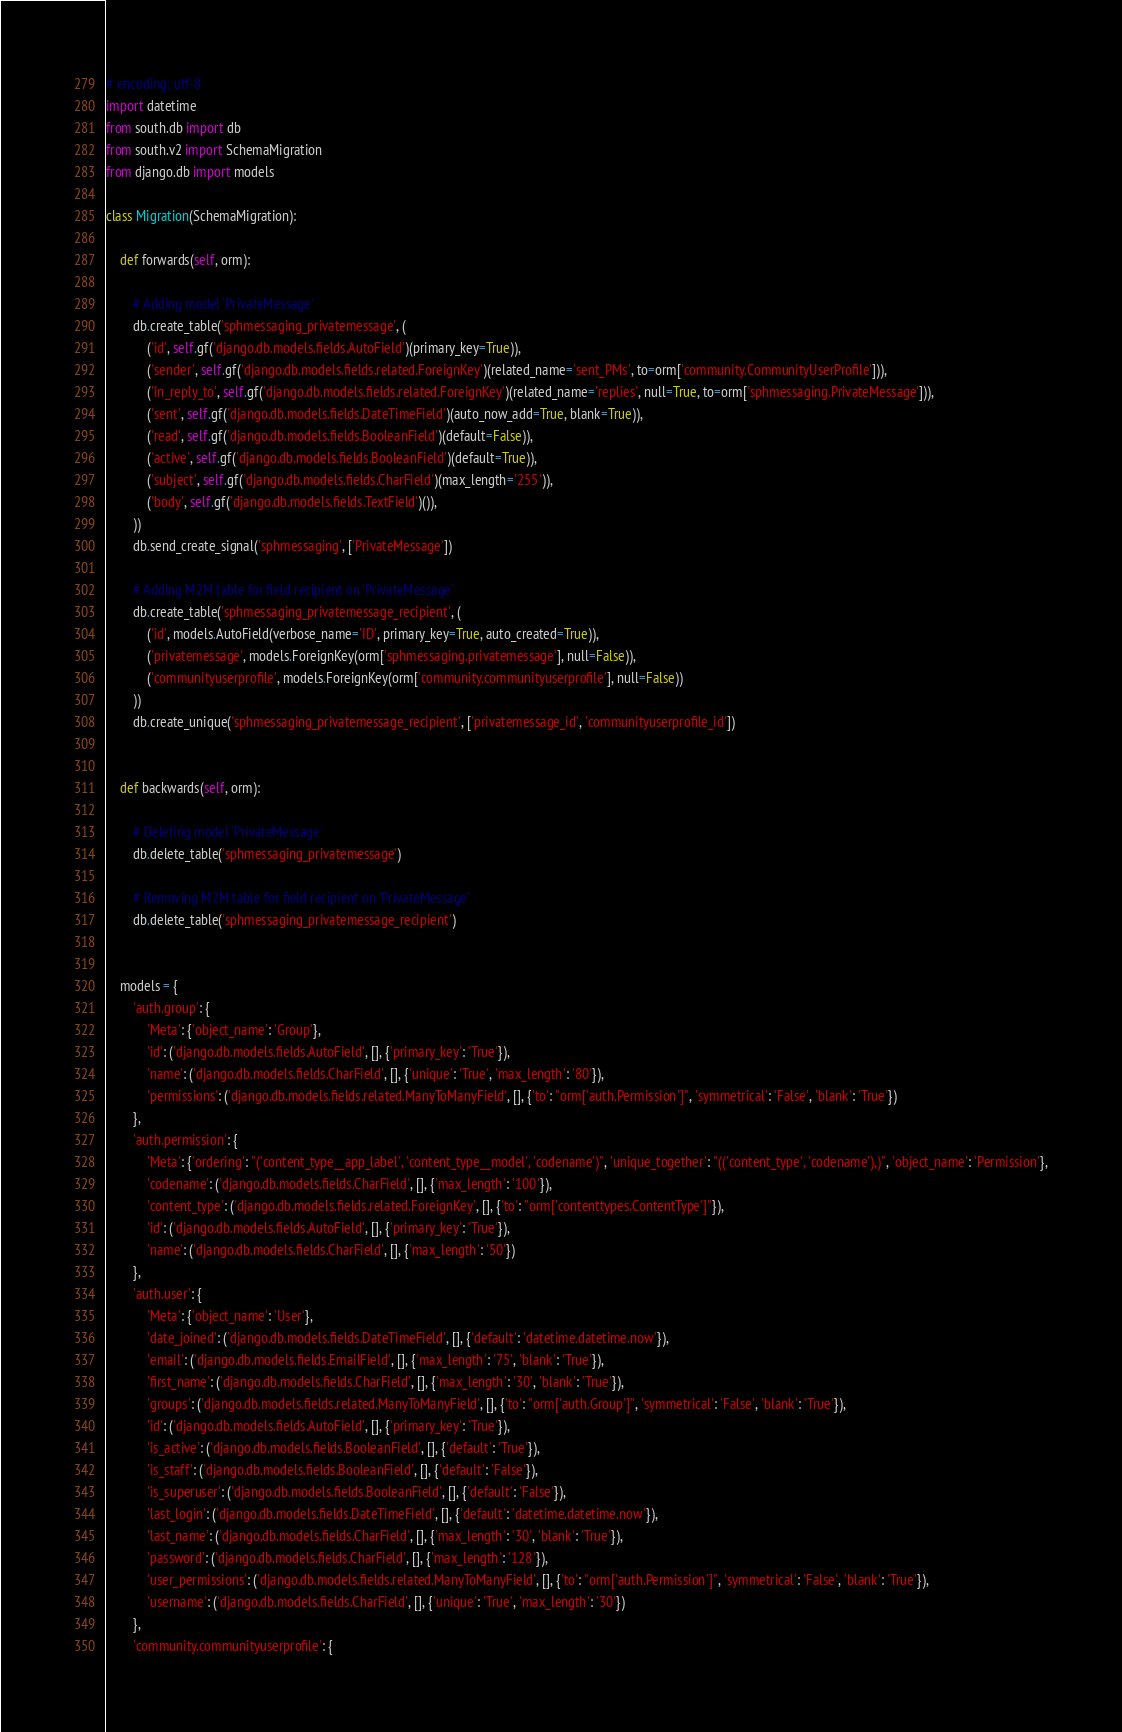<code> <loc_0><loc_0><loc_500><loc_500><_Python_># encoding: utf-8
import datetime
from south.db import db
from south.v2 import SchemaMigration
from django.db import models

class Migration(SchemaMigration):

    def forwards(self, orm):
        
        # Adding model 'PrivateMessage'
        db.create_table('sphmessaging_privatemessage', (
            ('id', self.gf('django.db.models.fields.AutoField')(primary_key=True)),
            ('sender', self.gf('django.db.models.fields.related.ForeignKey')(related_name='sent_PMs', to=orm['community.CommunityUserProfile'])),
            ('in_reply_to', self.gf('django.db.models.fields.related.ForeignKey')(related_name='replies', null=True, to=orm['sphmessaging.PrivateMessage'])),
            ('sent', self.gf('django.db.models.fields.DateTimeField')(auto_now_add=True, blank=True)),
            ('read', self.gf('django.db.models.fields.BooleanField')(default=False)),
            ('active', self.gf('django.db.models.fields.BooleanField')(default=True)),
            ('subject', self.gf('django.db.models.fields.CharField')(max_length='255')),
            ('body', self.gf('django.db.models.fields.TextField')()),
        ))
        db.send_create_signal('sphmessaging', ['PrivateMessage'])

        # Adding M2M table for field recipient on 'PrivateMessage'
        db.create_table('sphmessaging_privatemessage_recipient', (
            ('id', models.AutoField(verbose_name='ID', primary_key=True, auto_created=True)),
            ('privatemessage', models.ForeignKey(orm['sphmessaging.privatemessage'], null=False)),
            ('communityuserprofile', models.ForeignKey(orm['community.communityuserprofile'], null=False))
        ))
        db.create_unique('sphmessaging_privatemessage_recipient', ['privatemessage_id', 'communityuserprofile_id'])


    def backwards(self, orm):
        
        # Deleting model 'PrivateMessage'
        db.delete_table('sphmessaging_privatemessage')

        # Removing M2M table for field recipient on 'PrivateMessage'
        db.delete_table('sphmessaging_privatemessage_recipient')


    models = {
        'auth.group': {
            'Meta': {'object_name': 'Group'},
            'id': ('django.db.models.fields.AutoField', [], {'primary_key': 'True'}),
            'name': ('django.db.models.fields.CharField', [], {'unique': 'True', 'max_length': '80'}),
            'permissions': ('django.db.models.fields.related.ManyToManyField', [], {'to': "orm['auth.Permission']", 'symmetrical': 'False', 'blank': 'True'})
        },
        'auth.permission': {
            'Meta': {'ordering': "('content_type__app_label', 'content_type__model', 'codename')", 'unique_together': "(('content_type', 'codename'),)", 'object_name': 'Permission'},
            'codename': ('django.db.models.fields.CharField', [], {'max_length': '100'}),
            'content_type': ('django.db.models.fields.related.ForeignKey', [], {'to': "orm['contenttypes.ContentType']"}),
            'id': ('django.db.models.fields.AutoField', [], {'primary_key': 'True'}),
            'name': ('django.db.models.fields.CharField', [], {'max_length': '50'})
        },
        'auth.user': {
            'Meta': {'object_name': 'User'},
            'date_joined': ('django.db.models.fields.DateTimeField', [], {'default': 'datetime.datetime.now'}),
            'email': ('django.db.models.fields.EmailField', [], {'max_length': '75', 'blank': 'True'}),
            'first_name': ('django.db.models.fields.CharField', [], {'max_length': '30', 'blank': 'True'}),
            'groups': ('django.db.models.fields.related.ManyToManyField', [], {'to': "orm['auth.Group']", 'symmetrical': 'False', 'blank': 'True'}),
            'id': ('django.db.models.fields.AutoField', [], {'primary_key': 'True'}),
            'is_active': ('django.db.models.fields.BooleanField', [], {'default': 'True'}),
            'is_staff': ('django.db.models.fields.BooleanField', [], {'default': 'False'}),
            'is_superuser': ('django.db.models.fields.BooleanField', [], {'default': 'False'}),
            'last_login': ('django.db.models.fields.DateTimeField', [], {'default': 'datetime.datetime.now'}),
            'last_name': ('django.db.models.fields.CharField', [], {'max_length': '30', 'blank': 'True'}),
            'password': ('django.db.models.fields.CharField', [], {'max_length': '128'}),
            'user_permissions': ('django.db.models.fields.related.ManyToManyField', [], {'to': "orm['auth.Permission']", 'symmetrical': 'False', 'blank': 'True'}),
            'username': ('django.db.models.fields.CharField', [], {'unique': 'True', 'max_length': '30'})
        },
        'community.communityuserprofile': {</code> 